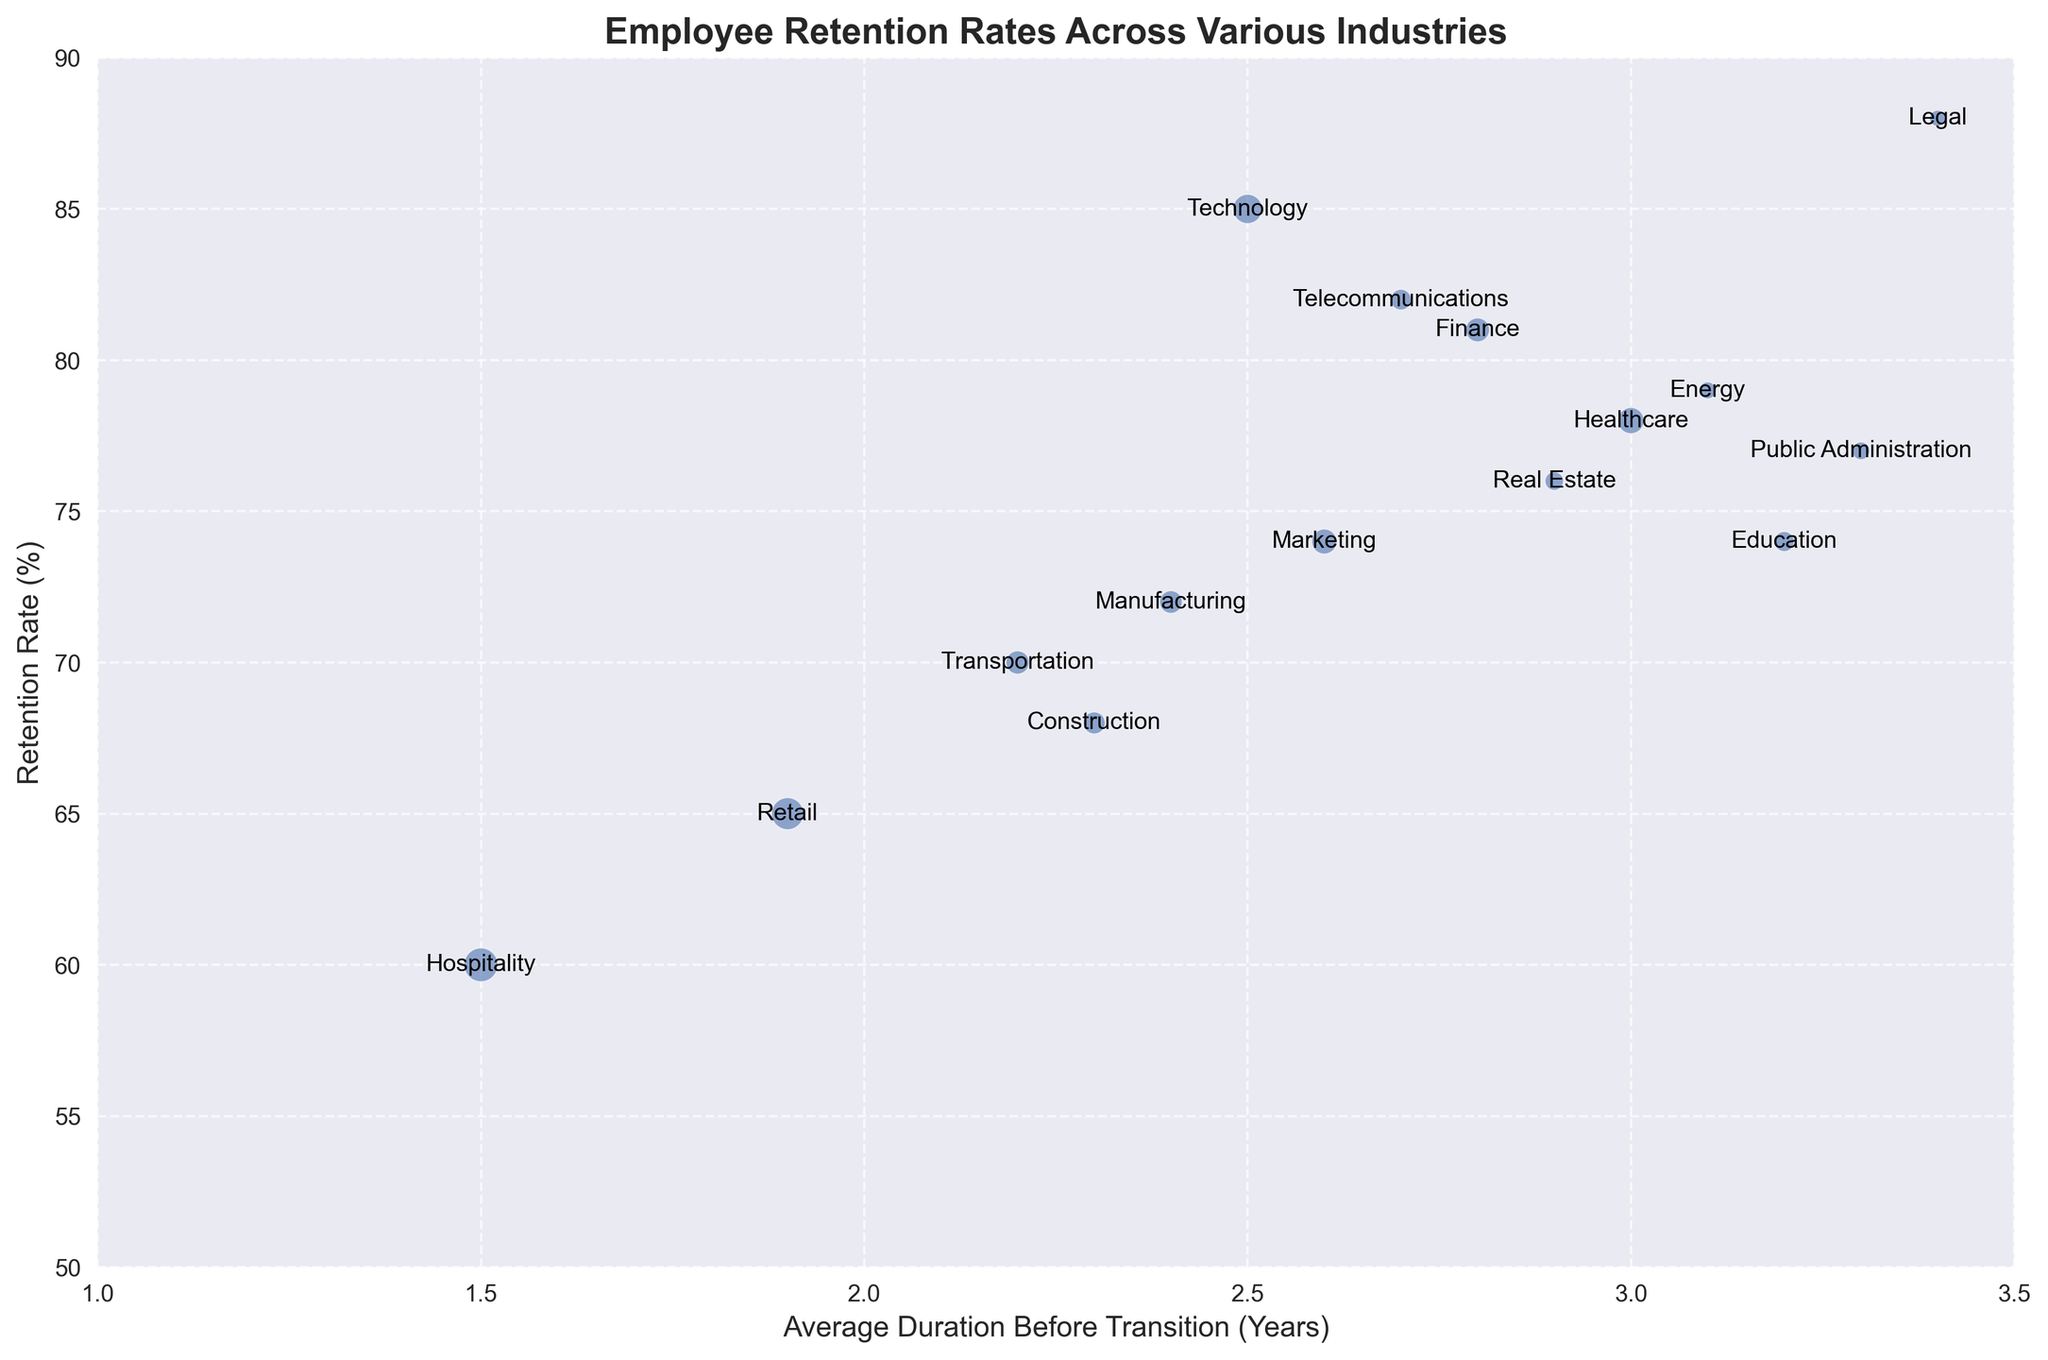Which industry has the highest retention rate, and what is its average duration before transition? First, locate the points representing each industry on the chart. Identify the point positioned highest on the y-axis, which signifies the highest retention rate. Check its corresponding x-axis value for the average duration before transition, labeled next to the point.
Answer: Legal, 3.4 years What is the difference in retention rates between Technology and Hospitality industries? Identify the y-axis positions of Technology and Hospitality. Technology is at 85%, and Hospitality is at 60%. Calculate the difference: 85 - 60.
Answer: 25% Which industry has the most job openings, and what are its retention rate and average duration before transition? Examine the sizes of the bubbles, as larger bubbles represent more job openings. The largest bubble corresponds to Hospitality. Check its y-axis (retention rate) and x-axis (average duration) values.
Answer: Hospitality, 60%, 1.5 years How does the average duration before transition in Education compare to that in Transportation? Find the x-axis positions of Education and Transportation. Education is at 3.2 years, and Transportation is at 2.2 years. Compare these values.
Answer: Education is 1 year longer Identify the industry with an approximate retention rate of 70% and provide its average duration before transition and average job openings. Locate the point around 70% on the y-axis. Transportation is near 70%. Its average duration is at 2.2 years on the x-axis, and its average job openings are labeled next to the point.
Answer: Transportation, 2.2 years, 95,000 What is the average retention rate of industries with job openings of approximately 100,000 or more? Identify bubbles with job openings around or above 100,000 (Technology, Healthcare, Finance, Retail, Hospitality, and Marketing). Their retention rates are 85%, 78%, 81%, 65%, 60%, and 74%. Calculate the average: (85 + 78 + 81 + 65 + 60 + 74) / 6.
Answer: 73.83% Which industry has an average duration before transition greater than that of Finance but lower than that of Legal? What are its retention rate and job openings? Identify industries with durations between Finance's 2.8 years and Legal's 3.4 years: Real Estate and Energy. Real Estate has a retention rate of 76% and 60,000 job openings. Energy has a retention rate of 79% and 50,000 job openings, and a transition duration of 3.1 years.
Answer: Energy, 79%, 50,000 